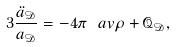Convert formula to latex. <formula><loc_0><loc_0><loc_500><loc_500>3 \frac { \ddot { a } _ { \mathcal { D } } } { a _ { \mathcal { D } } } = - 4 \pi \ a v { \rho } + \mathcal { Q } _ { \mathcal { D } } ,</formula> 